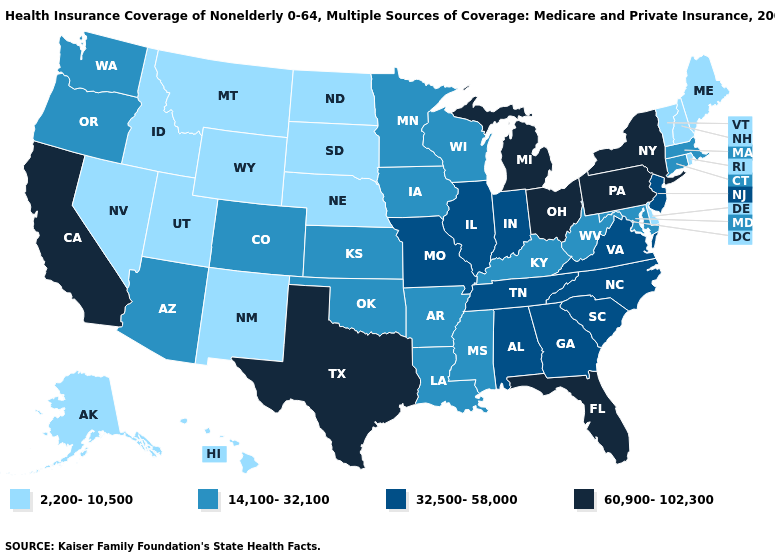Does Ohio have the lowest value in the USA?
Answer briefly. No. Name the states that have a value in the range 14,100-32,100?
Short answer required. Arizona, Arkansas, Colorado, Connecticut, Iowa, Kansas, Kentucky, Louisiana, Maryland, Massachusetts, Minnesota, Mississippi, Oklahoma, Oregon, Washington, West Virginia, Wisconsin. Which states have the lowest value in the USA?
Short answer required. Alaska, Delaware, Hawaii, Idaho, Maine, Montana, Nebraska, Nevada, New Hampshire, New Mexico, North Dakota, Rhode Island, South Dakota, Utah, Vermont, Wyoming. What is the lowest value in the Northeast?
Be succinct. 2,200-10,500. Does the first symbol in the legend represent the smallest category?
Keep it brief. Yes. Name the states that have a value in the range 14,100-32,100?
Keep it brief. Arizona, Arkansas, Colorado, Connecticut, Iowa, Kansas, Kentucky, Louisiana, Maryland, Massachusetts, Minnesota, Mississippi, Oklahoma, Oregon, Washington, West Virginia, Wisconsin. What is the lowest value in the USA?
Quick response, please. 2,200-10,500. Name the states that have a value in the range 14,100-32,100?
Concise answer only. Arizona, Arkansas, Colorado, Connecticut, Iowa, Kansas, Kentucky, Louisiana, Maryland, Massachusetts, Minnesota, Mississippi, Oklahoma, Oregon, Washington, West Virginia, Wisconsin. Name the states that have a value in the range 14,100-32,100?
Keep it brief. Arizona, Arkansas, Colorado, Connecticut, Iowa, Kansas, Kentucky, Louisiana, Maryland, Massachusetts, Minnesota, Mississippi, Oklahoma, Oregon, Washington, West Virginia, Wisconsin. What is the highest value in states that border Maine?
Write a very short answer. 2,200-10,500. Does the first symbol in the legend represent the smallest category?
Short answer required. Yes. What is the lowest value in the MidWest?
Give a very brief answer. 2,200-10,500. Does the first symbol in the legend represent the smallest category?
Give a very brief answer. Yes. What is the value of Oklahoma?
Answer briefly. 14,100-32,100. Is the legend a continuous bar?
Concise answer only. No. 